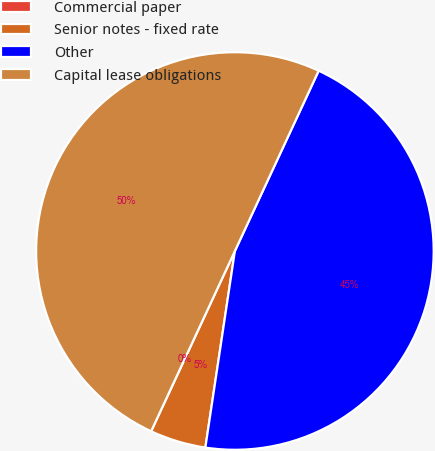<chart> <loc_0><loc_0><loc_500><loc_500><pie_chart><fcel>Commercial paper<fcel>Senior notes - fixed rate<fcel>Other<fcel>Capital lease obligations<nl><fcel>0.0%<fcel>4.55%<fcel>45.45%<fcel>50.0%<nl></chart> 